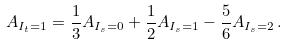Convert formula to latex. <formula><loc_0><loc_0><loc_500><loc_500>A _ { I _ { t } = 1 } = { \frac { 1 } { 3 } } A _ { I _ { s } = 0 } + { \frac { 1 } { 2 } } A _ { I _ { s } = 1 } - { \frac { 5 } { 6 } } A _ { I _ { s } = 2 } \, .</formula> 